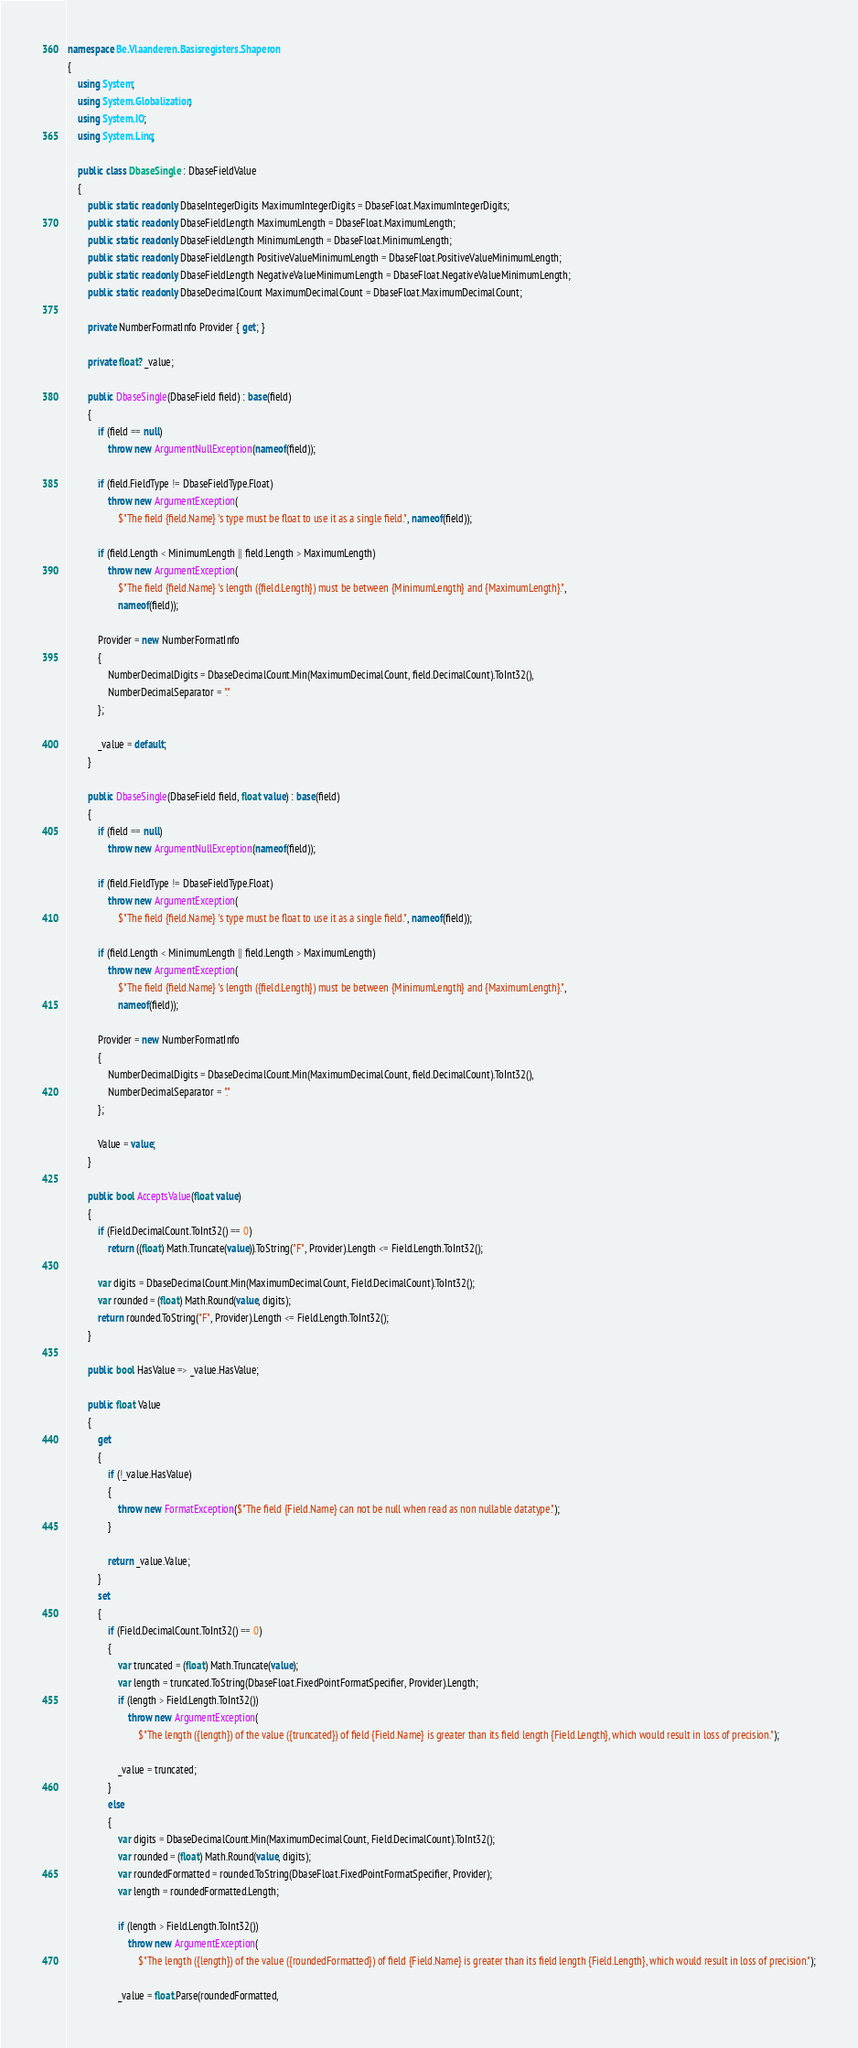Convert code to text. <code><loc_0><loc_0><loc_500><loc_500><_C#_>namespace Be.Vlaanderen.Basisregisters.Shaperon
{
    using System;
    using System.Globalization;
    using System.IO;
    using System.Linq;

    public class DbaseSingle : DbaseFieldValue
    {
        public static readonly DbaseIntegerDigits MaximumIntegerDigits = DbaseFloat.MaximumIntegerDigits;
        public static readonly DbaseFieldLength MaximumLength = DbaseFloat.MaximumLength;
        public static readonly DbaseFieldLength MinimumLength = DbaseFloat.MinimumLength;
        public static readonly DbaseFieldLength PositiveValueMinimumLength = DbaseFloat.PositiveValueMinimumLength;
        public static readonly DbaseFieldLength NegativeValueMinimumLength = DbaseFloat.NegativeValueMinimumLength;
        public static readonly DbaseDecimalCount MaximumDecimalCount = DbaseFloat.MaximumDecimalCount;

        private NumberFormatInfo Provider { get; }

        private float? _value;

        public DbaseSingle(DbaseField field) : base(field)
        {
            if (field == null)
                throw new ArgumentNullException(nameof(field));

            if (field.FieldType != DbaseFieldType.Float)
                throw new ArgumentException(
                    $"The field {field.Name} 's type must be float to use it as a single field.", nameof(field));

            if (field.Length < MinimumLength || field.Length > MaximumLength)
                throw new ArgumentException(
                    $"The field {field.Name} 's length ({field.Length}) must be between {MinimumLength} and {MaximumLength}.",
                    nameof(field));

            Provider = new NumberFormatInfo
            {
                NumberDecimalDigits = DbaseDecimalCount.Min(MaximumDecimalCount, field.DecimalCount).ToInt32(),
                NumberDecimalSeparator = "."
            };

            _value = default;
        }

        public DbaseSingle(DbaseField field, float value) : base(field)
        {
            if (field == null)
                throw new ArgumentNullException(nameof(field));

            if (field.FieldType != DbaseFieldType.Float)
                throw new ArgumentException(
                    $"The field {field.Name} 's type must be float to use it as a single field.", nameof(field));

            if (field.Length < MinimumLength || field.Length > MaximumLength)
                throw new ArgumentException(
                    $"The field {field.Name} 's length ({field.Length}) must be between {MinimumLength} and {MaximumLength}.",
                    nameof(field));

            Provider = new NumberFormatInfo
            {
                NumberDecimalDigits = DbaseDecimalCount.Min(MaximumDecimalCount, field.DecimalCount).ToInt32(),
                NumberDecimalSeparator = "."
            };

            Value = value;
        }

        public bool AcceptsValue(float value)
        {
            if (Field.DecimalCount.ToInt32() == 0)
                return ((float) Math.Truncate(value)).ToString("F", Provider).Length <= Field.Length.ToInt32();

            var digits = DbaseDecimalCount.Min(MaximumDecimalCount, Field.DecimalCount).ToInt32();
            var rounded = (float) Math.Round(value, digits);
            return rounded.ToString("F", Provider).Length <= Field.Length.ToInt32();
        }

        public bool HasValue => _value.HasValue;

        public float Value
        {
            get
            {
                if (!_value.HasValue)
                {
                    throw new FormatException($"The field {Field.Name} can not be null when read as non nullable datatype.");
                }

                return _value.Value;
            }
            set
            {
                if (Field.DecimalCount.ToInt32() == 0)
                {
                    var truncated = (float) Math.Truncate(value);
                    var length = truncated.ToString(DbaseFloat.FixedPointFormatSpecifier, Provider).Length;
                    if (length > Field.Length.ToInt32())
                        throw new ArgumentException(
                            $"The length ({length}) of the value ({truncated}) of field {Field.Name} is greater than its field length {Field.Length}, which would result in loss of precision.");

                    _value = truncated;
                }
                else
                {
                    var digits = DbaseDecimalCount.Min(MaximumDecimalCount, Field.DecimalCount).ToInt32();
                    var rounded = (float) Math.Round(value, digits);
                    var roundedFormatted = rounded.ToString(DbaseFloat.FixedPointFormatSpecifier, Provider);
                    var length = roundedFormatted.Length;

                    if (length > Field.Length.ToInt32())
                        throw new ArgumentException(
                            $"The length ({length}) of the value ({roundedFormatted}) of field {Field.Name} is greater than its field length {Field.Length}, which would result in loss of precision.");

                    _value = float.Parse(roundedFormatted,</code> 